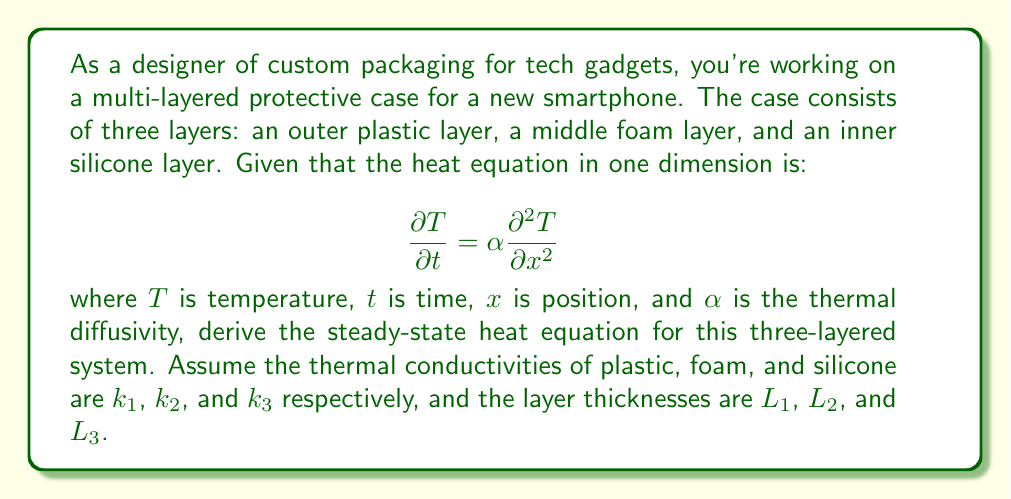Give your solution to this math problem. To solve this problem, we'll follow these steps:

1) In steady-state, the temperature doesn't change with time, so $\frac{\partial T}{\partial t} = 0$.

2) For each layer, the steady-state heat equation becomes:

   $$\frac{d^2 T}{dx^2} = 0$$

3) The general solution for each layer is:

   $$T_i(x) = A_i x + B_i$$

   where $i = 1, 2, 3$ for the three layers.

4) At the interfaces between layers, we have two conditions:
   a) Temperature continuity: $T_i = T_{i+1}$
   b) Heat flux continuity: $k_i \frac{dT_i}{dx} = k_{i+1} \frac{dT_{i+1}}{dx}$

5) Applying these conditions:

   At $x = L_1$: 
   $$A_1 L_1 + B_1 = A_2 L_1 + B_2$$
   $$k_1 A_1 = k_2 A_2$$

   At $x = L_1 + L_2$:
   $$A_2 (L_1 + L_2) + B_2 = A_3 (L_1 + L_2) + B_3$$
   $$k_2 A_2 = k_3 A_3$$

6) The overall temperature difference $\Delta T$ across the three layers is:

   $$\Delta T = [A_3 (L_1 + L_2 + L_3) + B_3] - [B_1]$$

7) The heat flux $q$ is constant through all layers:

   $$q = -k_1 A_1 = -k_2 A_2 = -k_3 A_3$$

8) Substituting and solving, we get:

   $$\Delta T = q (\frac{L_1}{k_1} + \frac{L_2}{k_2} + \frac{L_3}{k_3})$$

9) Rearranging, we get the final steady-state heat equation for the three-layered system:

   $$q = \frac{\Delta T}{\frac{L_1}{k_1} + \frac{L_2}{k_2} + \frac{L_3}{k_3}}$$
Answer: $$q = \frac{\Delta T}{\frac{L_1}{k_1} + \frac{L_2}{k_2} + \frac{L_3}{k_3}}$$ 